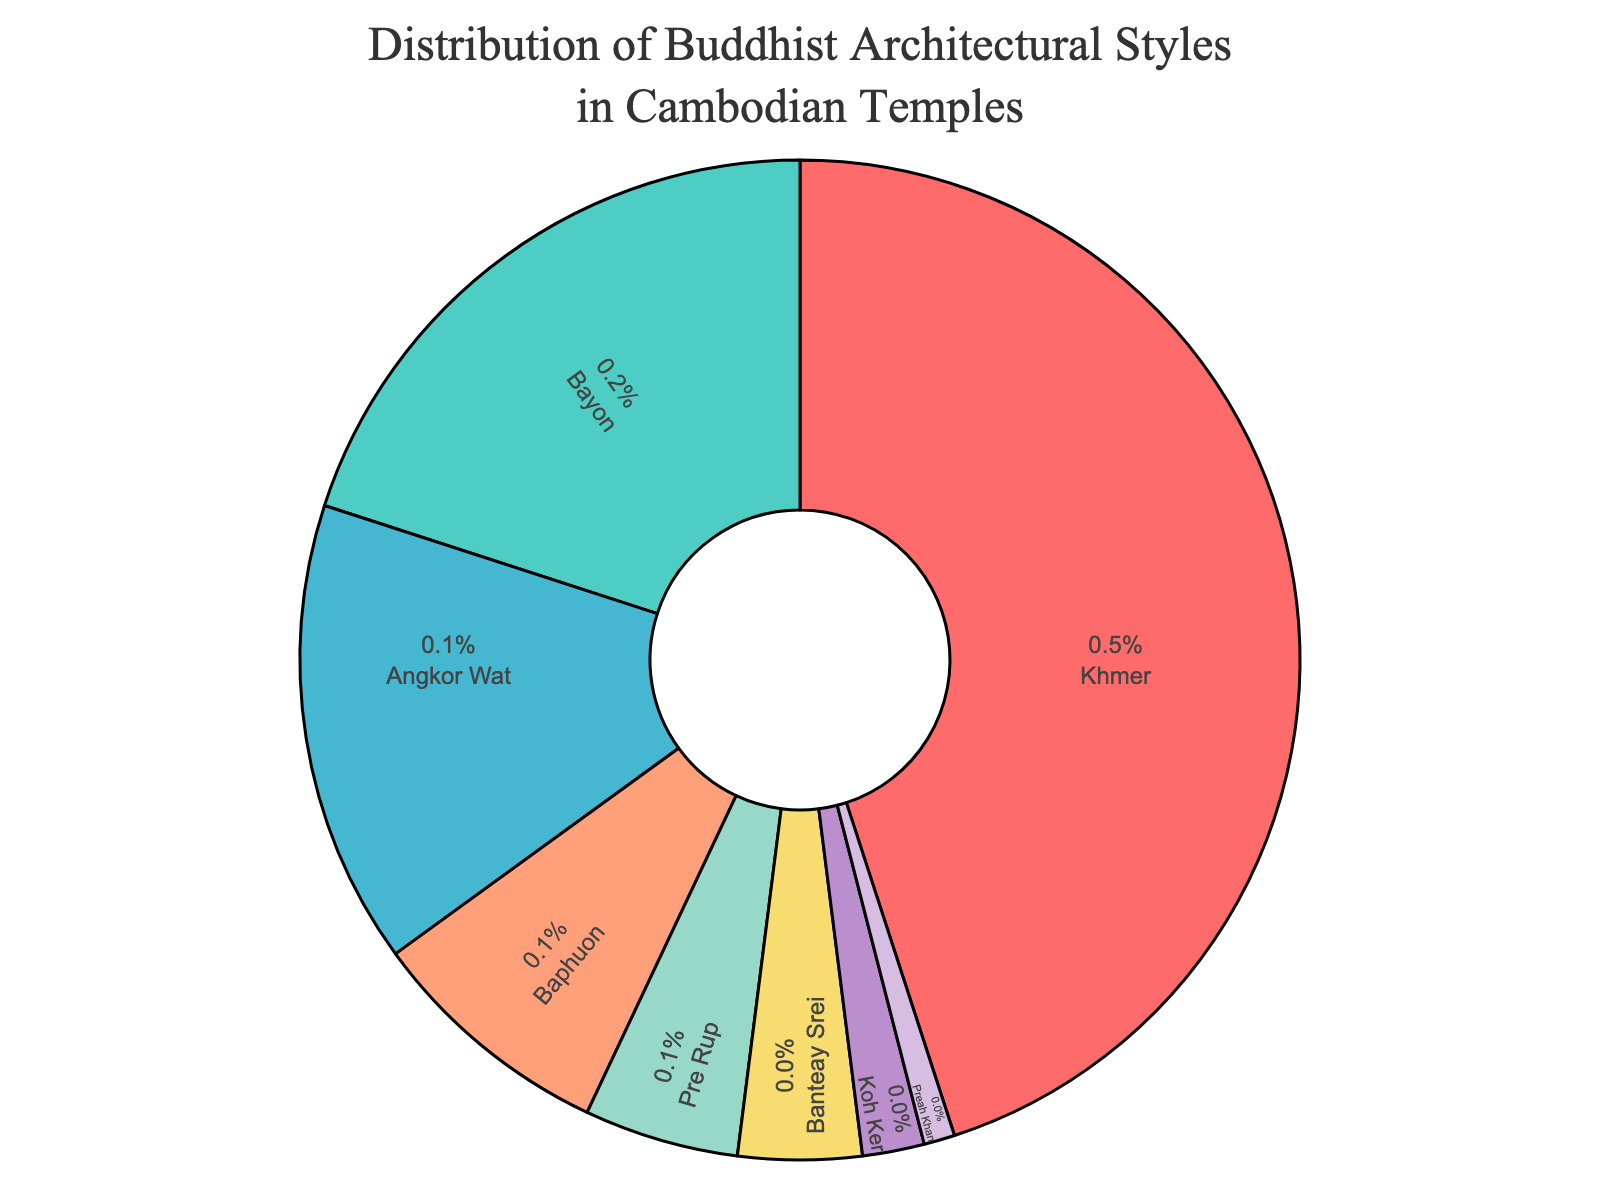Which architectural style has the highest percentage? The figure shows different architectural styles, and from the percentages inside the pie chart, Khmer has the highest percentage.
Answer: Khmer How much higher is the percentage of Bayon style compared to Pre Rup style? By looking at the pie chart, Bayon style has 20% and Pre Rup style has 5%. The difference is calculated as 20% - 5% = 15%.
Answer: 15% What percentage of the total is represented by Angkor Wat and Baphuon styles combined? According to the figure, Angkor Wat has 15% and Baphuon has 8%. Therefore, the total percentage is 15% + 8% = 23%.
Answer: 23% Which styles make up less than 5% of the distribution? The styles with percentages less than 5% are Banteay Srei, Koh Ker, and Preah Khan according to the pie chart information.
Answer: Banteay Srei, Koh Ker, Preah Khan Is the percentage of Khmer style more than double that of Bayon style? The percentage of Khmer style is 45% and that of Bayon is 20%. Since 45% is indeed more than double of 20% (which would be 40%), this statement is true.
Answer: Yes What is the combined percentage of the three smallest segments presented in the pie chart? The three smallest segments are Koh Ker (2%), Preah Khan (1%), and Banteay Srei (4%). Adding these gives 2% + 1% + 4% = 7%.
Answer: 7% Which color corresponds to the Baphuon style in the chart? By understanding the color segments in the pie chart, Baphuon style is represented by the yellowish color.
Answer: Yellowish How does the percentage of Pre Rup style compare with Banteay Srei style? From the pie chart, Pre Rup has 5% while Banteay Srei has 4%. Thus, Pre Rup style has a 1% higher percentage than Banteay Srei style.
Answer: 1% higher What is the significant visual feature of the most abundant architectural style? The most abundant architectural style is Khmer, which dominates the largest portion of the pie chart. It is notably marked in red.
Answer: Red If we exclude Khmer and Bayon styles, what percentage remains represented by all other styles combined? By excluding Khmer (45%) and Bayon (20%), we add up the other percentages: Angkor Wat (15%) + Baphuon (8%) + Pre Rup (5%) + Banteay Srei (4%) + Koh Ker (2%) + Preah Khan (1%). This sums to 35%.
Answer: 35% 